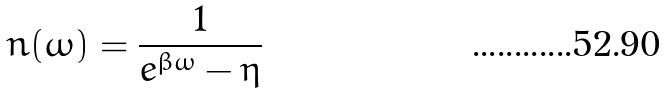Convert formula to latex. <formula><loc_0><loc_0><loc_500><loc_500>n ( \omega ) = \frac { 1 } { e ^ { \beta \omega } - \eta }</formula> 